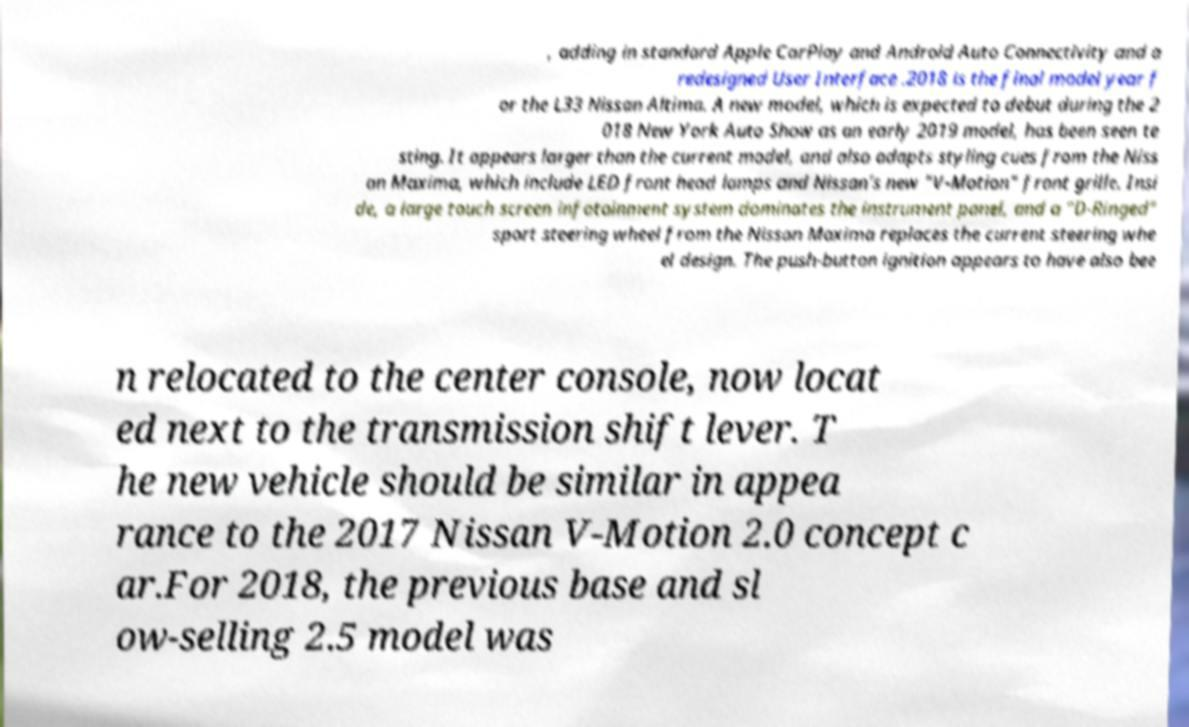Please identify and transcribe the text found in this image. , adding in standard Apple CarPlay and Android Auto Connectivity and a redesigned User Interface .2018 is the final model year f or the L33 Nissan Altima. A new model, which is expected to debut during the 2 018 New York Auto Show as an early 2019 model, has been seen te sting. It appears larger than the current model, and also adapts styling cues from the Niss an Maxima, which include LED front head lamps and Nissan's new "V-Motion" front grille. Insi de, a large touch screen infotainment system dominates the instrument panel, and a "D-Ringed" sport steering wheel from the Nissan Maxima replaces the current steering whe el design. The push-button ignition appears to have also bee n relocated to the center console, now locat ed next to the transmission shift lever. T he new vehicle should be similar in appea rance to the 2017 Nissan V-Motion 2.0 concept c ar.For 2018, the previous base and sl ow-selling 2.5 model was 